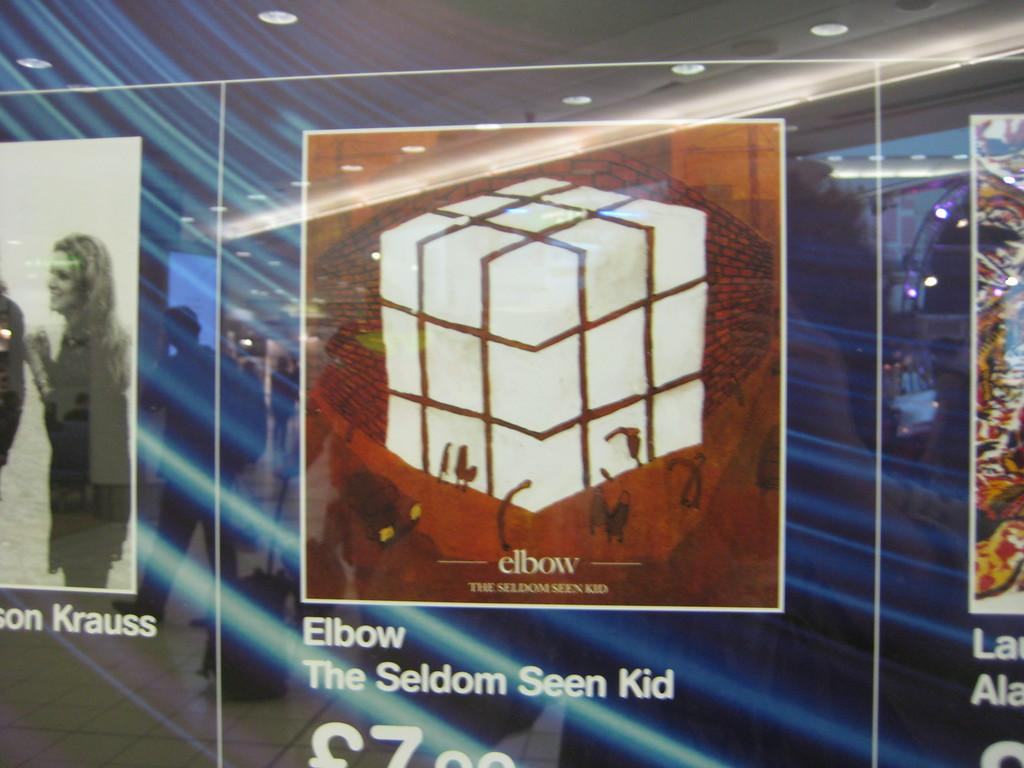<image>
Describe the image concisely. A poster for a book name Elbow The Seldom Seen Kid. 